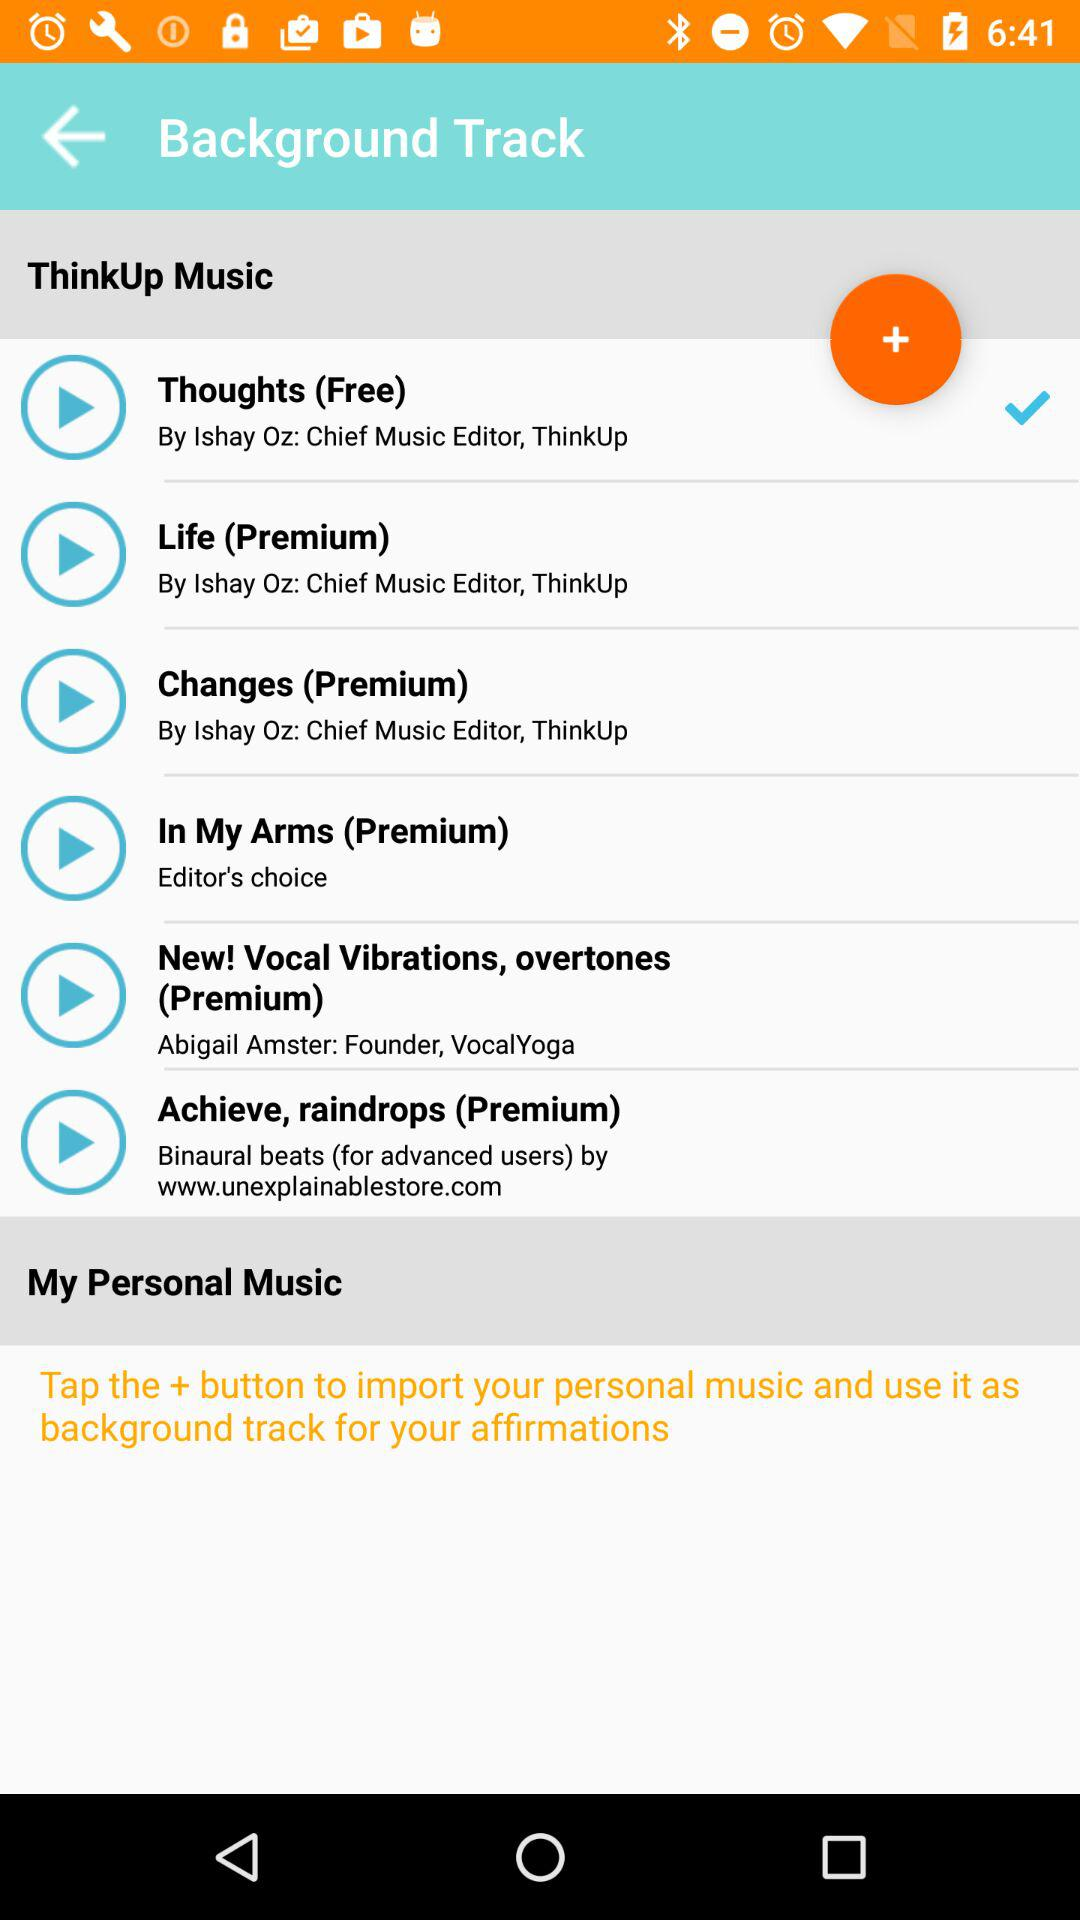What are the names of the songs in "Premium"? The names of the songs are "Life", "Changes", "In My Arms", "New! Vocal Vibrations, overtones" and "Achieve, raindrops". 